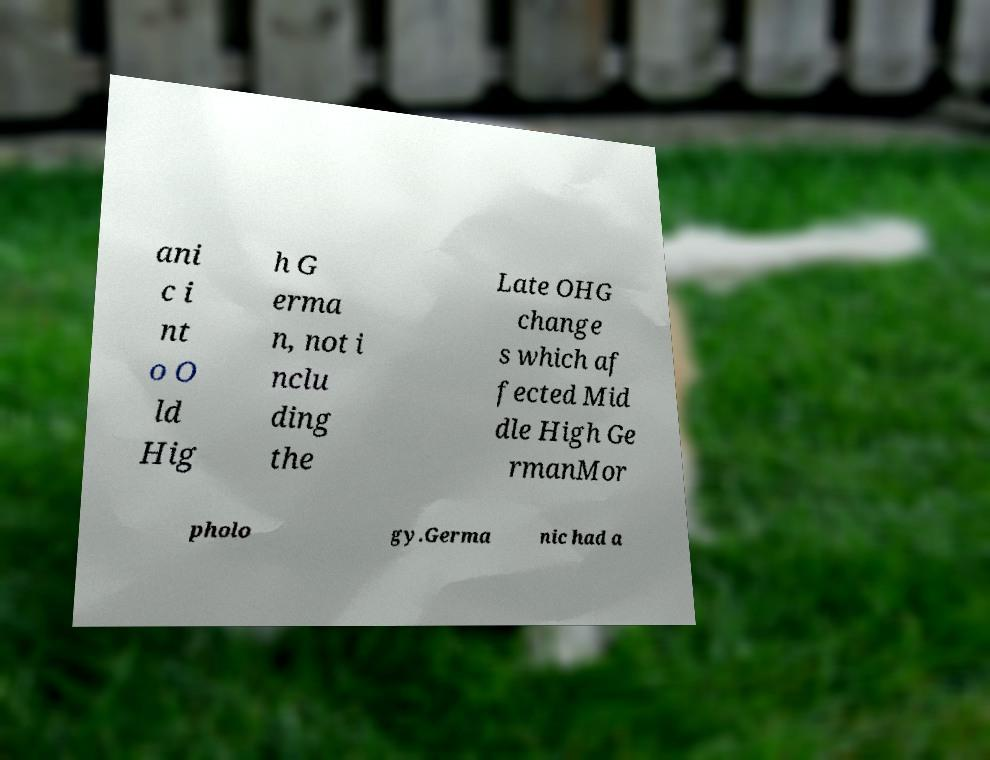Can you read and provide the text displayed in the image?This photo seems to have some interesting text. Can you extract and type it out for me? ani c i nt o O ld Hig h G erma n, not i nclu ding the Late OHG change s which af fected Mid dle High Ge rmanMor pholo gy.Germa nic had a 